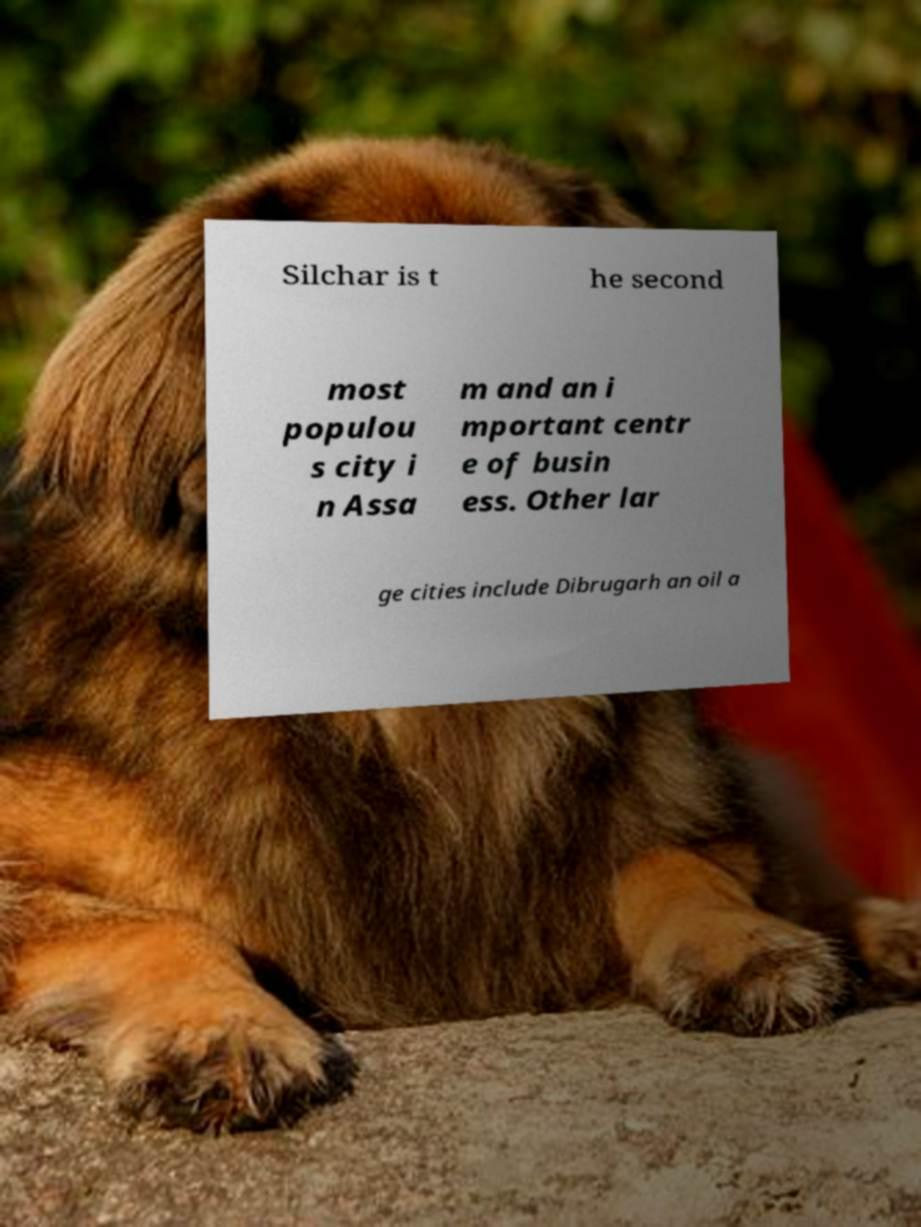There's text embedded in this image that I need extracted. Can you transcribe it verbatim? Silchar is t he second most populou s city i n Assa m and an i mportant centr e of busin ess. Other lar ge cities include Dibrugarh an oil a 